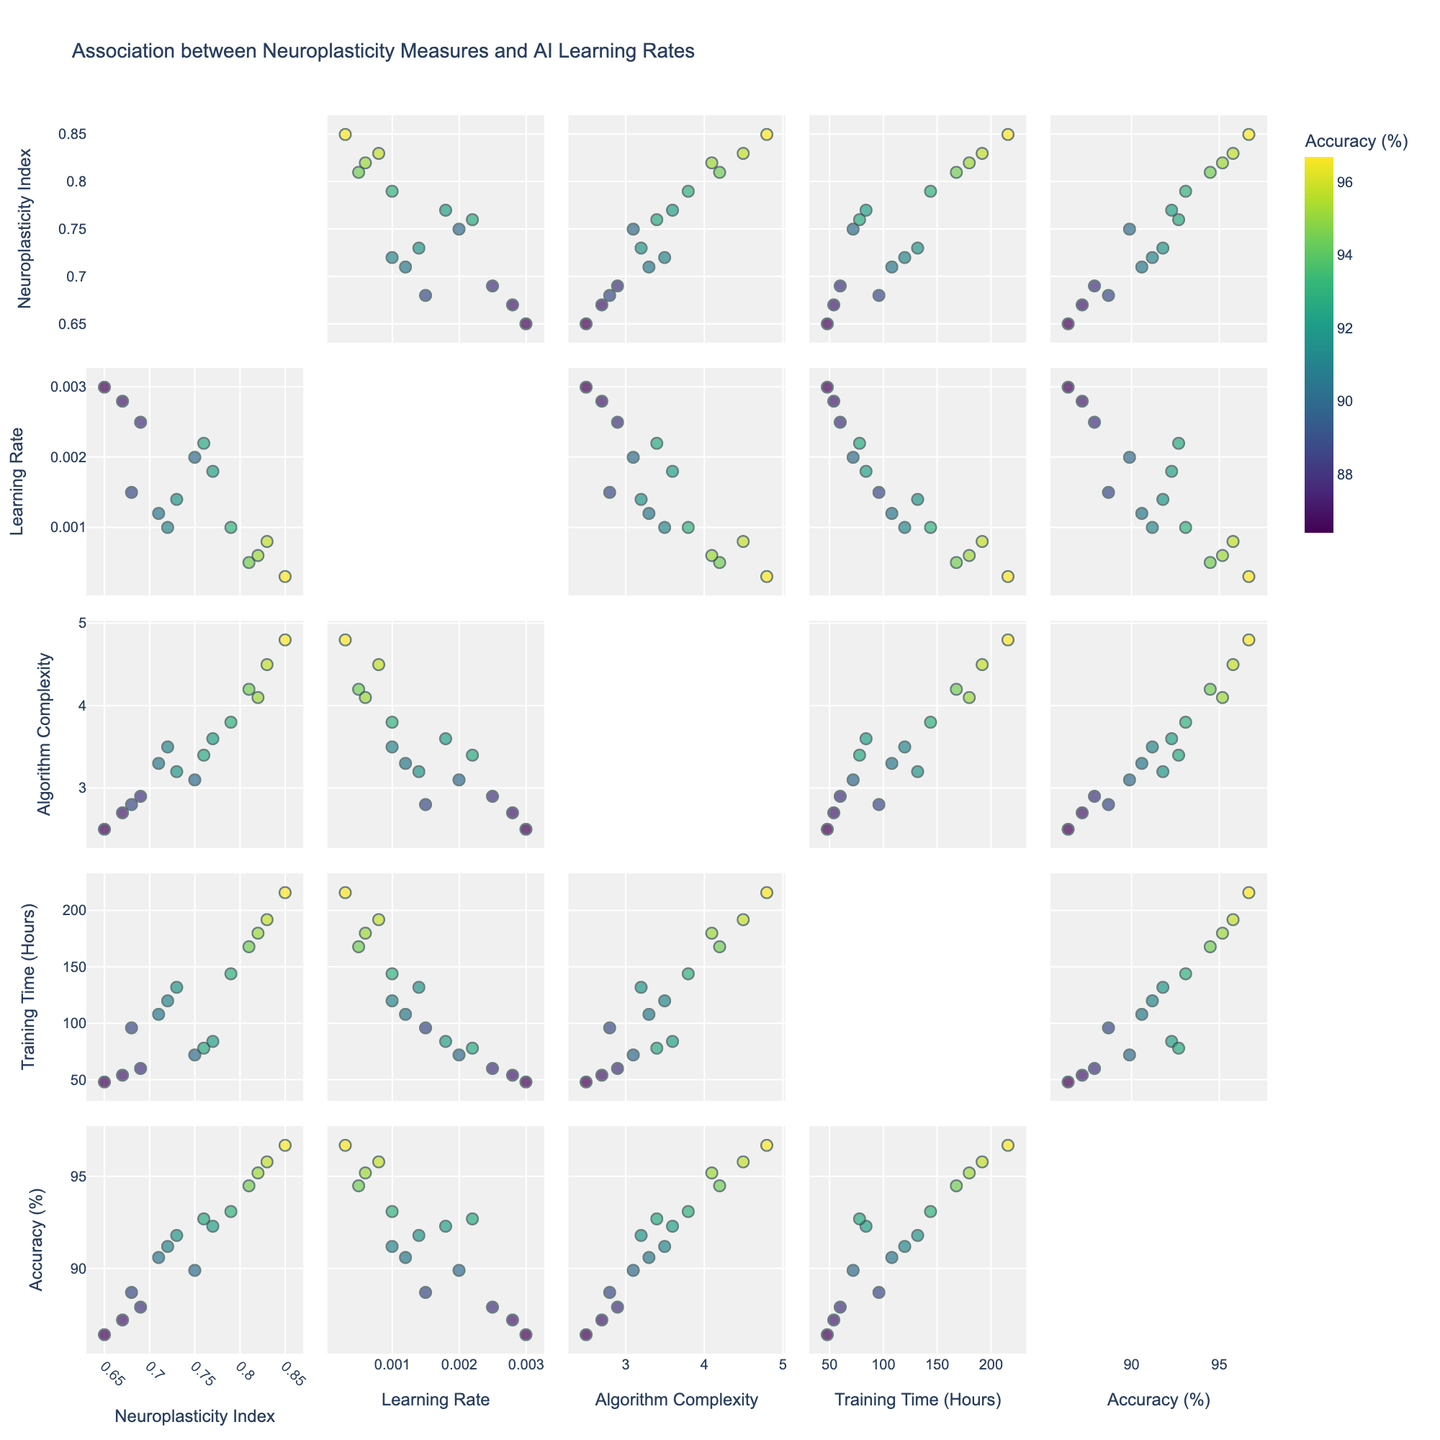What is the title of the scatterplot matrix? The title is located at the top of the scatterplot matrix, typically in a larger font size for visibility.
Answer: Association between Neuroplasticity Measures and AI Learning Rates How many data points are presented in the figure? Each dot in the scatterplot matrix represents a data point. By counting all the dots across various scatter plots, we see there are 15 data points.
Answer: 15 Which variable is represented using color in the scatterplot matrix? The color bar on the right side of the figure labeled 'Accuracy (%)' indicates the coloring scheme used.
Answer: Accuracy Percentage Which pair of variables shows the strongest positive correlation? By visually inspecting the scatterplots, we look for the pair with the most pronounced upward trend. The 'Neuroplasticity Index' and 'Accuracy Percentage' plot shows the strongest positive correlation.
Answer: Neuroplasticity Index and Accuracy Percentage Is there any pair of variables that exhibits a negative correlation? We look for scatterplots with a downward trend. The 'Learning Rate' and 'Accuracy Percentage' plot exhibits a slight negative correlation, where higher learning rates correspond to lower accuracy.
Answer: Learning Rate and Accuracy Percentage What is the range of the Neuroplasticity Index in the dataset? By checking the axis limits and min/max values on plots involving 'Neuroplasticity Index', we see that it ranges from 0.65 to 0.85.
Answer: 0.65 to 0.85 Which combination of variables has the highest algorithm complexity and what is the corresponding accuracy percentage? We identify the point with the highest value on the 'Algorithm Complexity' axis in any scatterplot. It occurs at an 'Algorithm Complexity' of 4.8, and the corresponding 'Accuracy Percentage' is 96.7%.
Answer: Algorithm Complexity 4.8, Accuracy Percentage 96.7% What is the correlation between Training Time and Accuracy Percentage? By observing the scatter plot of 'Training Time (Hours)' versus 'Accuracy Percentage', there’s a positive trend, indicating a positive correlation. Longer training times generally correspond to higher accuracy percentages.
Answer: Positive correlation How does the learning rate affect the training time? Scanning plots of 'Learning Rate' against 'Training Time (Hours)', there's a general downward trend indicating that higher learning rates tend to reduce training time.
Answer: Higher learning rates reduce training time Which variables seem to cluster together and might require further investigation? Focusing on the scatterplots where data points form visible clusters, the plots involving 'Neuroplasticity Index', 'Algorithm Complexity', and 'Accuracy Percentage' tend to form more discernible clusters.
Answer: Neuroplasticity Index, Algorithm Complexity, and Accuracy Percentage 